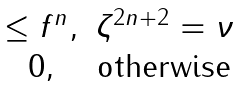Convert formula to latex. <formula><loc_0><loc_0><loc_500><loc_500>\begin{matrix} \leq f ^ { n } , & \zeta ^ { 2 n + 2 } = \nu \\ 0 , & \text {otherwise} \end{matrix}</formula> 